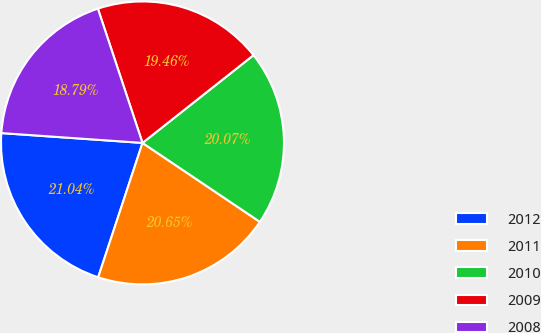Convert chart. <chart><loc_0><loc_0><loc_500><loc_500><pie_chart><fcel>2012<fcel>2011<fcel>2010<fcel>2009<fcel>2008<nl><fcel>21.04%<fcel>20.65%<fcel>20.07%<fcel>19.46%<fcel>18.79%<nl></chart> 